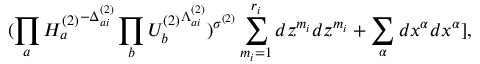<formula> <loc_0><loc_0><loc_500><loc_500>( \prod _ { a } { H _ { a } ^ { ( 2 ) } } ^ { - \Delta _ { a i } ^ { ( 2 ) } } \prod _ { b } { U _ { b } ^ { ( 2 ) } } ^ { \Lambda _ { a i } ^ { ( 2 ) } } ) ^ { \sigma ^ { ( 2 ) } } \sum _ { m _ { i } = 1 } ^ { r _ { i } } d z ^ { m _ { i } } d z ^ { m _ { i } } + \sum _ { \alpha } d x ^ { \alpha } d x ^ { \alpha } ] ,</formula> 